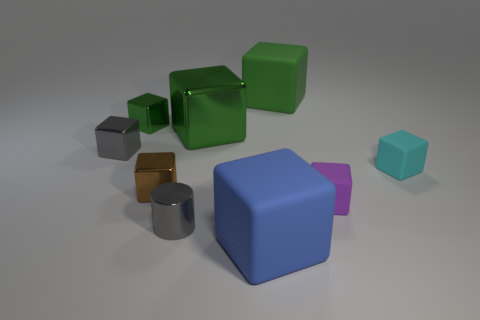Subtract all brown cylinders. How many green cubes are left? 3 Subtract all blue blocks. How many blocks are left? 7 Subtract all small metal cubes. How many cubes are left? 5 Subtract 2 cubes. How many cubes are left? 6 Subtract all yellow blocks. Subtract all gray cylinders. How many blocks are left? 8 Subtract all cylinders. How many objects are left? 8 Add 9 small cyan cubes. How many small cyan cubes exist? 10 Subtract 0 purple balls. How many objects are left? 9 Subtract all blue cylinders. Subtract all purple matte blocks. How many objects are left? 8 Add 1 gray blocks. How many gray blocks are left? 2 